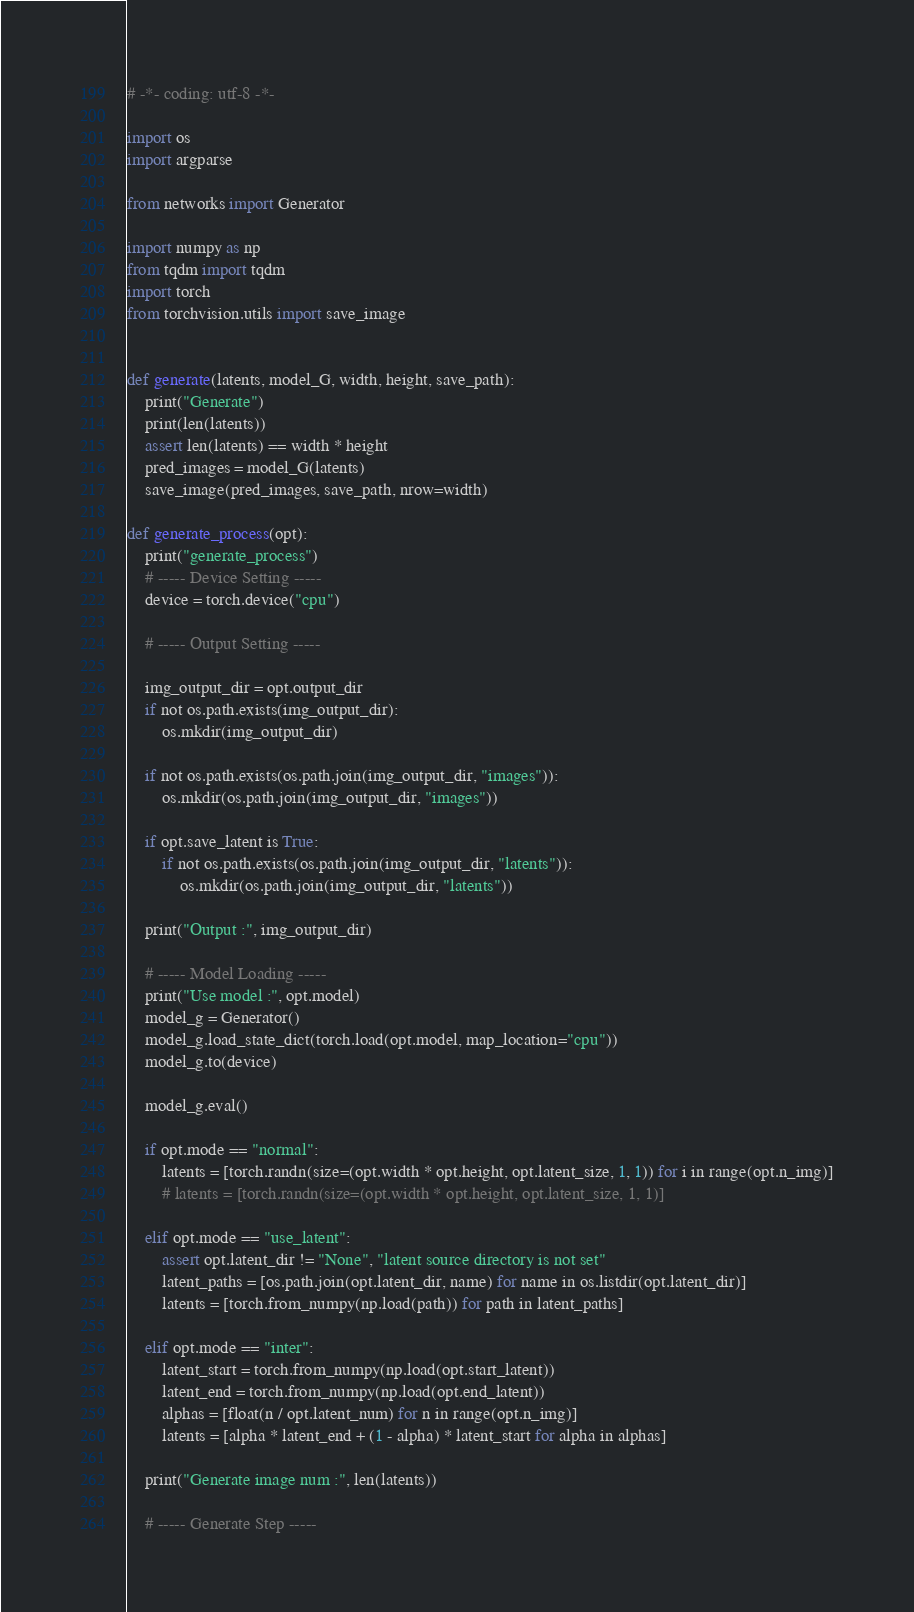Convert code to text. <code><loc_0><loc_0><loc_500><loc_500><_Python_># -*- coding: utf-8 -*-

import os
import argparse

from networks import Generator

import numpy as np
from tqdm import tqdm
import torch
from torchvision.utils import save_image


def generate(latents, model_G, width, height, save_path):
    print("Generate")
    print(len(latents))
    assert len(latents) == width * height
    pred_images = model_G(latents)
    save_image(pred_images, save_path, nrow=width)

def generate_process(opt):
    print("generate_process")
    # ----- Device Setting -----
    device = torch.device("cpu")

    # ----- Output Setting -----

    img_output_dir = opt.output_dir
    if not os.path.exists(img_output_dir):
        os.mkdir(img_output_dir)

    if not os.path.exists(os.path.join(img_output_dir, "images")):
        os.mkdir(os.path.join(img_output_dir, "images"))

    if opt.save_latent is True:
        if not os.path.exists(os.path.join(img_output_dir, "latents")):
            os.mkdir(os.path.join(img_output_dir, "latents"))

    print("Output :", img_output_dir)

    # ----- Model Loading -----
    print("Use model :", opt.model)
    model_g = Generator()
    model_g.load_state_dict(torch.load(opt.model, map_location="cpu"))
    model_g.to(device)

    model_g.eval()

    if opt.mode == "normal":
        latents = [torch.randn(size=(opt.width * opt.height, opt.latent_size, 1, 1)) for i in range(opt.n_img)]
        # latents = [torch.randn(size=(opt.width * opt.height, opt.latent_size, 1, 1)]

    elif opt.mode == "use_latent":
        assert opt.latent_dir != "None", "latent source directory is not set"
        latent_paths = [os.path.join(opt.latent_dir, name) for name in os.listdir(opt.latent_dir)]
        latents = [torch.from_numpy(np.load(path)) for path in latent_paths]

    elif opt.mode == "inter":
        latent_start = torch.from_numpy(np.load(opt.start_latent))
        latent_end = torch.from_numpy(np.load(opt.end_latent))
        alphas = [float(n / opt.latent_num) for n in range(opt.n_img)]
        latents = [alpha * latent_end + (1 - alpha) * latent_start for alpha in alphas]

    print("Generate image num :", len(latents))

    # ----- Generate Step -----</code> 